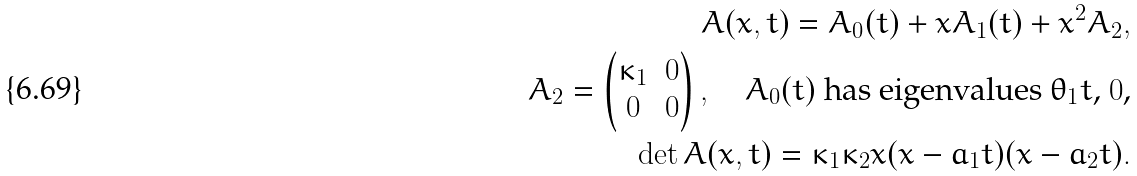Convert formula to latex. <formula><loc_0><loc_0><loc_500><loc_500>A ( x , t ) = A _ { 0 } ( t ) + x A _ { 1 } ( t ) + x ^ { 2 } A _ { 2 } , \\ A _ { 2 } = \begin{pmatrix} \kappa _ { 1 } & 0 \\ 0 & 0 \end{pmatrix} , \quad \text {$A_{0}(t)$ has eigenvalues $\theta_{1} t$, $0$,} \\ \det A ( x , t ) = \kappa _ { 1 } \kappa _ { 2 } x ( x - a _ { 1 } t ) ( x - a _ { 2 } t ) .</formula> 